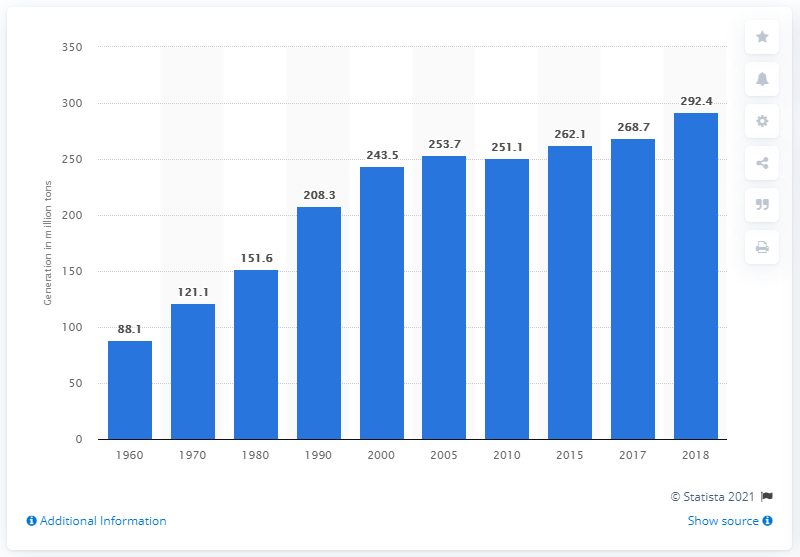Draw attention to some important aspects in this diagram. In 2018, the United States generated approximately 292,400,000 tons of municipal solid waste. In 1960, the United States generated 88.1 million short tons of municipal solid waste. 